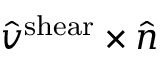<formula> <loc_0><loc_0><loc_500><loc_500>\hat { v } ^ { s h e a r } \times \hat { n }</formula> 